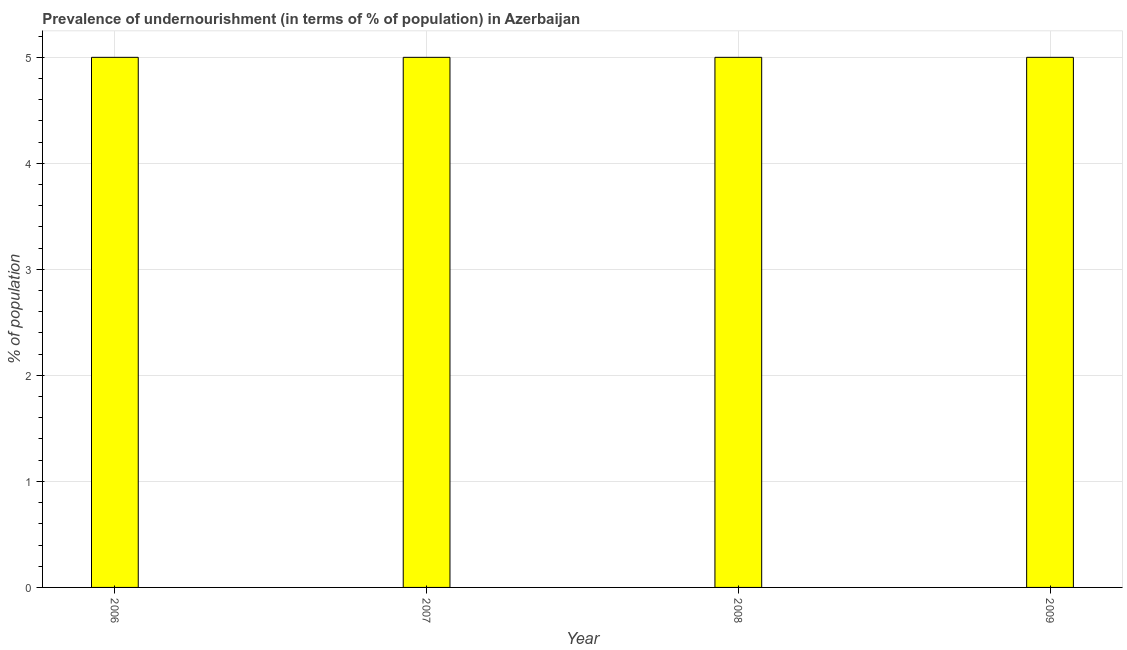What is the title of the graph?
Provide a succinct answer. Prevalence of undernourishment (in terms of % of population) in Azerbaijan. What is the label or title of the X-axis?
Make the answer very short. Year. What is the label or title of the Y-axis?
Offer a very short reply. % of population. Across all years, what is the maximum percentage of undernourished population?
Keep it short and to the point. 5. In which year was the percentage of undernourished population maximum?
Provide a short and direct response. 2006. In which year was the percentage of undernourished population minimum?
Your answer should be compact. 2006. What is the sum of the percentage of undernourished population?
Make the answer very short. 20. What is the average percentage of undernourished population per year?
Your answer should be compact. 5. What is the median percentage of undernourished population?
Offer a very short reply. 5. In how many years, is the percentage of undernourished population greater than 4.8 %?
Ensure brevity in your answer.  4. Is the percentage of undernourished population in 2006 less than that in 2007?
Ensure brevity in your answer.  No. What is the difference between the highest and the second highest percentage of undernourished population?
Give a very brief answer. 0. What is the difference between the highest and the lowest percentage of undernourished population?
Provide a succinct answer. 0. In how many years, is the percentage of undernourished population greater than the average percentage of undernourished population taken over all years?
Give a very brief answer. 0. Are all the bars in the graph horizontal?
Offer a very short reply. No. What is the difference between two consecutive major ticks on the Y-axis?
Keep it short and to the point. 1. Are the values on the major ticks of Y-axis written in scientific E-notation?
Ensure brevity in your answer.  No. What is the % of population in 2006?
Make the answer very short. 5. What is the % of population in 2007?
Ensure brevity in your answer.  5. What is the % of population of 2008?
Your response must be concise. 5. What is the % of population in 2009?
Your response must be concise. 5. What is the difference between the % of population in 2006 and 2007?
Provide a succinct answer. 0. What is the difference between the % of population in 2006 and 2008?
Provide a short and direct response. 0. What is the difference between the % of population in 2007 and 2008?
Provide a succinct answer. 0. What is the difference between the % of population in 2007 and 2009?
Make the answer very short. 0. What is the difference between the % of population in 2008 and 2009?
Provide a short and direct response. 0. What is the ratio of the % of population in 2006 to that in 2007?
Offer a very short reply. 1. What is the ratio of the % of population in 2006 to that in 2009?
Offer a terse response. 1. What is the ratio of the % of population in 2008 to that in 2009?
Keep it short and to the point. 1. 